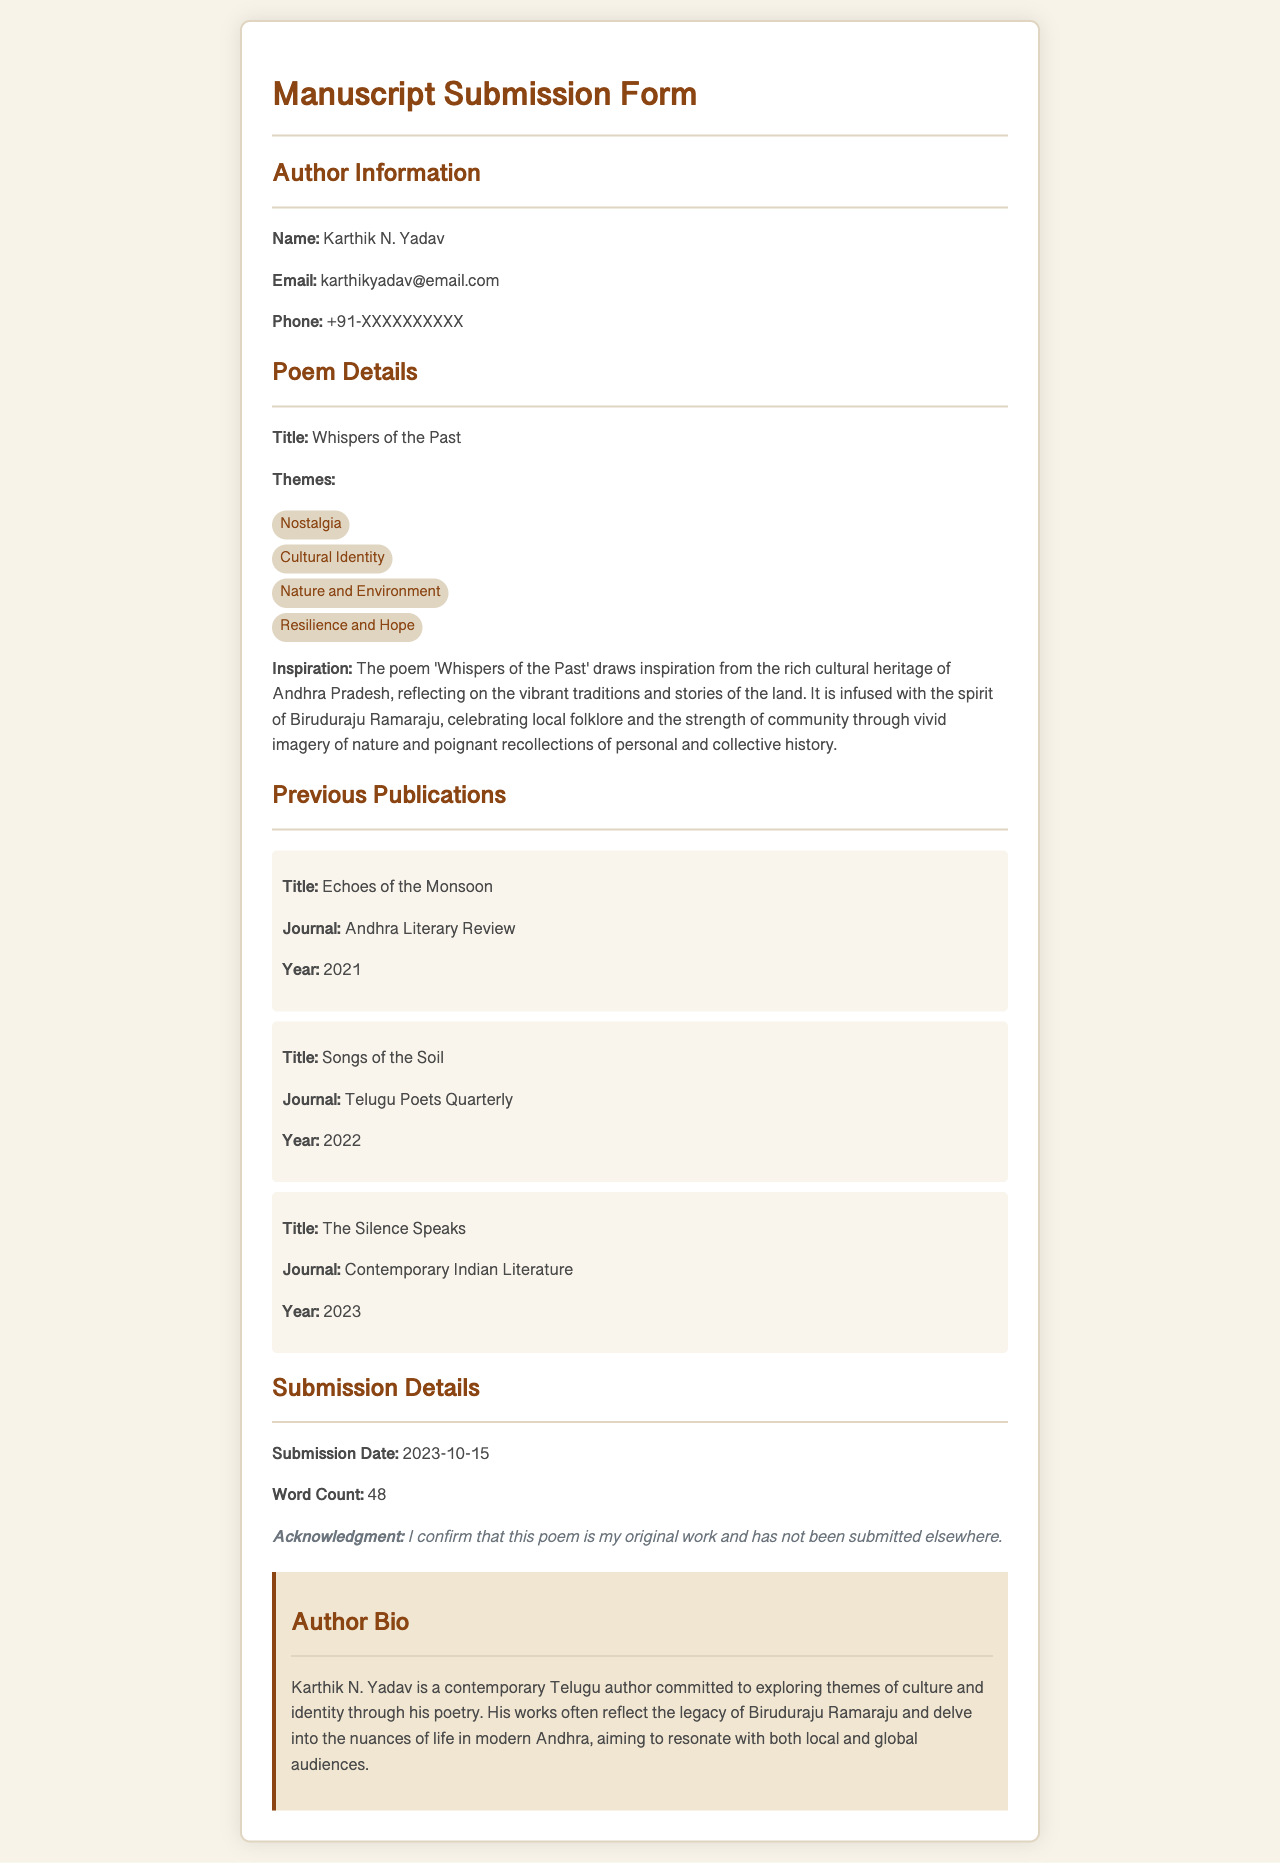What is the author's name? The author's name is mentioned in the Author Information section of the document.
Answer: Karthik N. Yadav What is the title of the poem? The poem's title is provided in the Poem Details section.
Answer: Whispers of the Past What are the themes listed for the poem? The themes of the poem are listed in the Poem Details section as bullet points, with four themes mentioned.
Answer: Nostalgia, Cultural Identity, Nature and Environment, Resilience and Hope What is the submission date? The submission date is indicated in the Submission Details section.
Answer: 2023-10-15 How many previous publications does the author have listed? The number of previous publications can be counted from the Published Works section, where three publications are provided.
Answer: 3 What is the year of the author's publication titled "Songs of the Soil"? The year of this publication is stated in the Previous Publications section.
Answer: 2022 What inspired the poem "Whispers of the Past"? The inspiration for the poem is detailed in the Poem Details section, addressing the influences behind the work.
Answer: The rich cultural heritage of Andhra Pradesh What is the word count of the poem? The word count is provided in the Submission Details section.
Answer: 48 What journal was "Echoes of the Monsoon" published in? The journal's name is referenced in the Previous Publications section under that publication.
Answer: Andhra Literary Review 